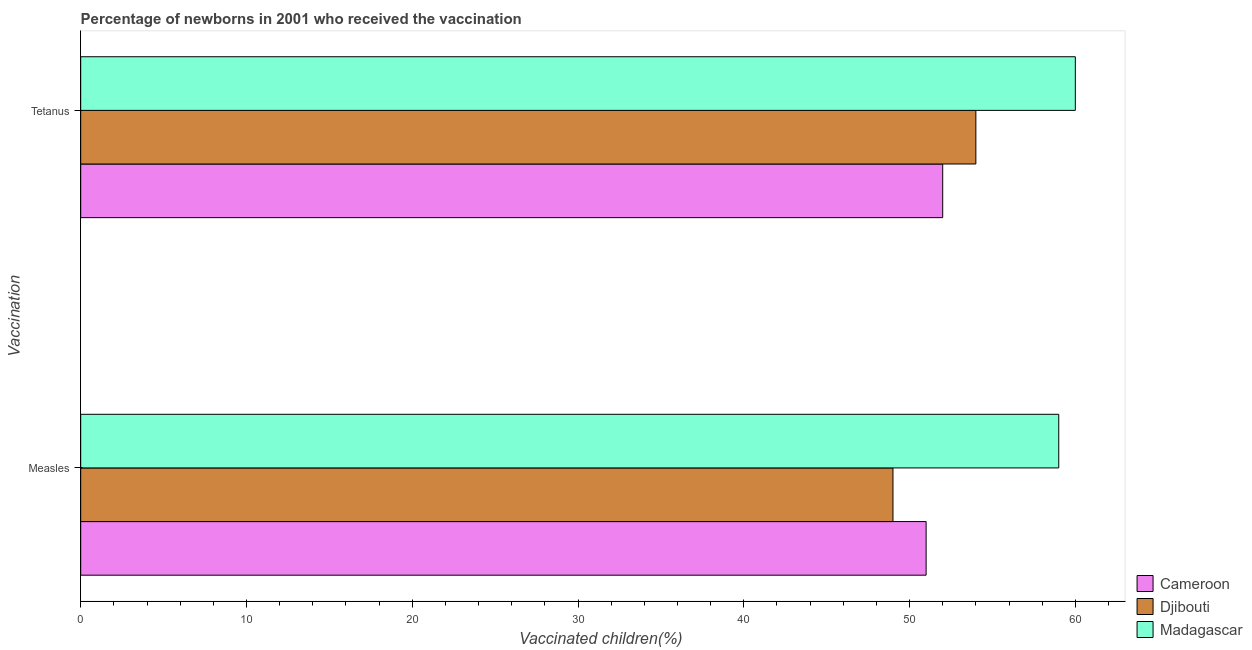Are the number of bars per tick equal to the number of legend labels?
Your response must be concise. Yes. Are the number of bars on each tick of the Y-axis equal?
Offer a very short reply. Yes. How many bars are there on the 2nd tick from the top?
Your response must be concise. 3. What is the label of the 2nd group of bars from the top?
Give a very brief answer. Measles. What is the percentage of newborns who received vaccination for measles in Madagascar?
Give a very brief answer. 59. Across all countries, what is the maximum percentage of newborns who received vaccination for tetanus?
Offer a very short reply. 60. Across all countries, what is the minimum percentage of newborns who received vaccination for tetanus?
Keep it short and to the point. 52. In which country was the percentage of newborns who received vaccination for tetanus maximum?
Make the answer very short. Madagascar. In which country was the percentage of newborns who received vaccination for measles minimum?
Your response must be concise. Djibouti. What is the total percentage of newborns who received vaccination for measles in the graph?
Your answer should be very brief. 159. What is the difference between the percentage of newborns who received vaccination for measles in Djibouti and that in Madagascar?
Ensure brevity in your answer.  -10. What is the difference between the percentage of newborns who received vaccination for tetanus in Cameroon and the percentage of newborns who received vaccination for measles in Madagascar?
Give a very brief answer. -7. What is the average percentage of newborns who received vaccination for tetanus per country?
Provide a short and direct response. 55.33. What is the difference between the percentage of newborns who received vaccination for tetanus and percentage of newborns who received vaccination for measles in Madagascar?
Offer a very short reply. 1. In how many countries, is the percentage of newborns who received vaccination for tetanus greater than 32 %?
Offer a very short reply. 3. What is the ratio of the percentage of newborns who received vaccination for tetanus in Djibouti to that in Cameroon?
Offer a terse response. 1.04. Is the percentage of newborns who received vaccination for measles in Djibouti less than that in Cameroon?
Provide a succinct answer. Yes. What does the 1st bar from the top in Tetanus represents?
Offer a very short reply. Madagascar. What does the 2nd bar from the bottom in Measles represents?
Give a very brief answer. Djibouti. Are all the bars in the graph horizontal?
Offer a very short reply. Yes. How many countries are there in the graph?
Keep it short and to the point. 3. What is the difference between two consecutive major ticks on the X-axis?
Your answer should be very brief. 10. Does the graph contain any zero values?
Make the answer very short. No. Does the graph contain grids?
Your answer should be compact. No. How many legend labels are there?
Offer a very short reply. 3. How are the legend labels stacked?
Make the answer very short. Vertical. What is the title of the graph?
Ensure brevity in your answer.  Percentage of newborns in 2001 who received the vaccination. What is the label or title of the X-axis?
Provide a short and direct response. Vaccinated children(%)
. What is the label or title of the Y-axis?
Keep it short and to the point. Vaccination. What is the Vaccinated children(%)
 of Madagascar in Measles?
Offer a very short reply. 59. What is the Vaccinated children(%)
 in Djibouti in Tetanus?
Offer a terse response. 54. Across all Vaccination, what is the maximum Vaccinated children(%)
 of Cameroon?
Offer a very short reply. 52. Across all Vaccination, what is the maximum Vaccinated children(%)
 in Djibouti?
Your response must be concise. 54. Across all Vaccination, what is the maximum Vaccinated children(%)
 in Madagascar?
Make the answer very short. 60. Across all Vaccination, what is the minimum Vaccinated children(%)
 of Cameroon?
Ensure brevity in your answer.  51. What is the total Vaccinated children(%)
 of Cameroon in the graph?
Your answer should be very brief. 103. What is the total Vaccinated children(%)
 in Djibouti in the graph?
Provide a short and direct response. 103. What is the total Vaccinated children(%)
 in Madagascar in the graph?
Provide a succinct answer. 119. What is the difference between the Vaccinated children(%)
 of Djibouti in Measles and that in Tetanus?
Your answer should be very brief. -5. What is the difference between the Vaccinated children(%)
 in Cameroon in Measles and the Vaccinated children(%)
 in Djibouti in Tetanus?
Offer a terse response. -3. What is the average Vaccinated children(%)
 in Cameroon per Vaccination?
Your answer should be very brief. 51.5. What is the average Vaccinated children(%)
 in Djibouti per Vaccination?
Offer a very short reply. 51.5. What is the average Vaccinated children(%)
 in Madagascar per Vaccination?
Provide a short and direct response. 59.5. What is the difference between the Vaccinated children(%)
 of Cameroon and Vaccinated children(%)
 of Djibouti in Measles?
Make the answer very short. 2. What is the difference between the Vaccinated children(%)
 in Cameroon and Vaccinated children(%)
 in Djibouti in Tetanus?
Your answer should be compact. -2. What is the ratio of the Vaccinated children(%)
 of Cameroon in Measles to that in Tetanus?
Make the answer very short. 0.98. What is the ratio of the Vaccinated children(%)
 of Djibouti in Measles to that in Tetanus?
Your answer should be compact. 0.91. What is the ratio of the Vaccinated children(%)
 of Madagascar in Measles to that in Tetanus?
Ensure brevity in your answer.  0.98. What is the difference between the highest and the second highest Vaccinated children(%)
 of Cameroon?
Provide a short and direct response. 1. What is the difference between the highest and the second highest Vaccinated children(%)
 in Djibouti?
Provide a short and direct response. 5. What is the difference between the highest and the lowest Vaccinated children(%)
 in Cameroon?
Offer a terse response. 1. What is the difference between the highest and the lowest Vaccinated children(%)
 in Djibouti?
Give a very brief answer. 5. What is the difference between the highest and the lowest Vaccinated children(%)
 in Madagascar?
Your answer should be compact. 1. 